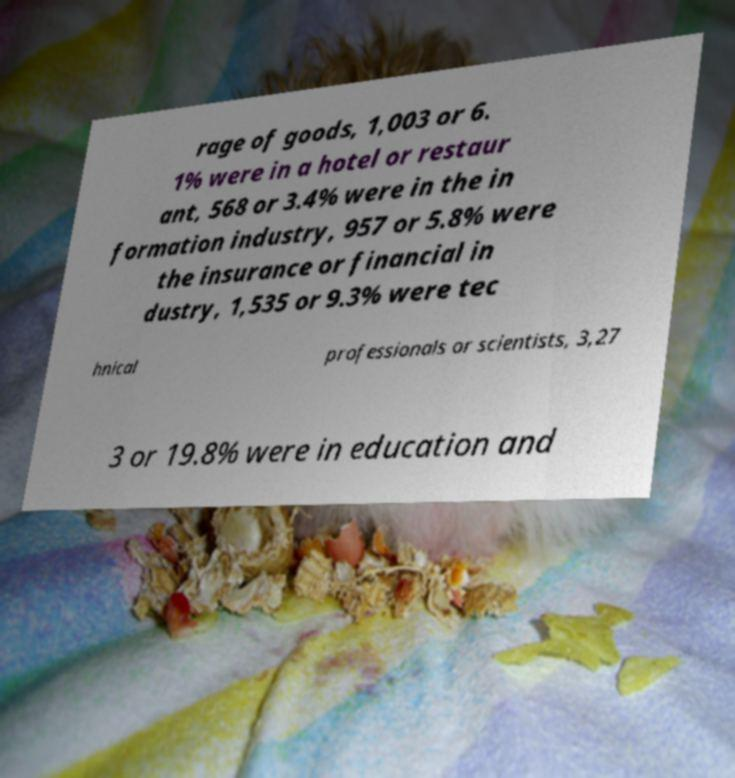Can you accurately transcribe the text from the provided image for me? rage of goods, 1,003 or 6. 1% were in a hotel or restaur ant, 568 or 3.4% were in the in formation industry, 957 or 5.8% were the insurance or financial in dustry, 1,535 or 9.3% were tec hnical professionals or scientists, 3,27 3 or 19.8% were in education and 